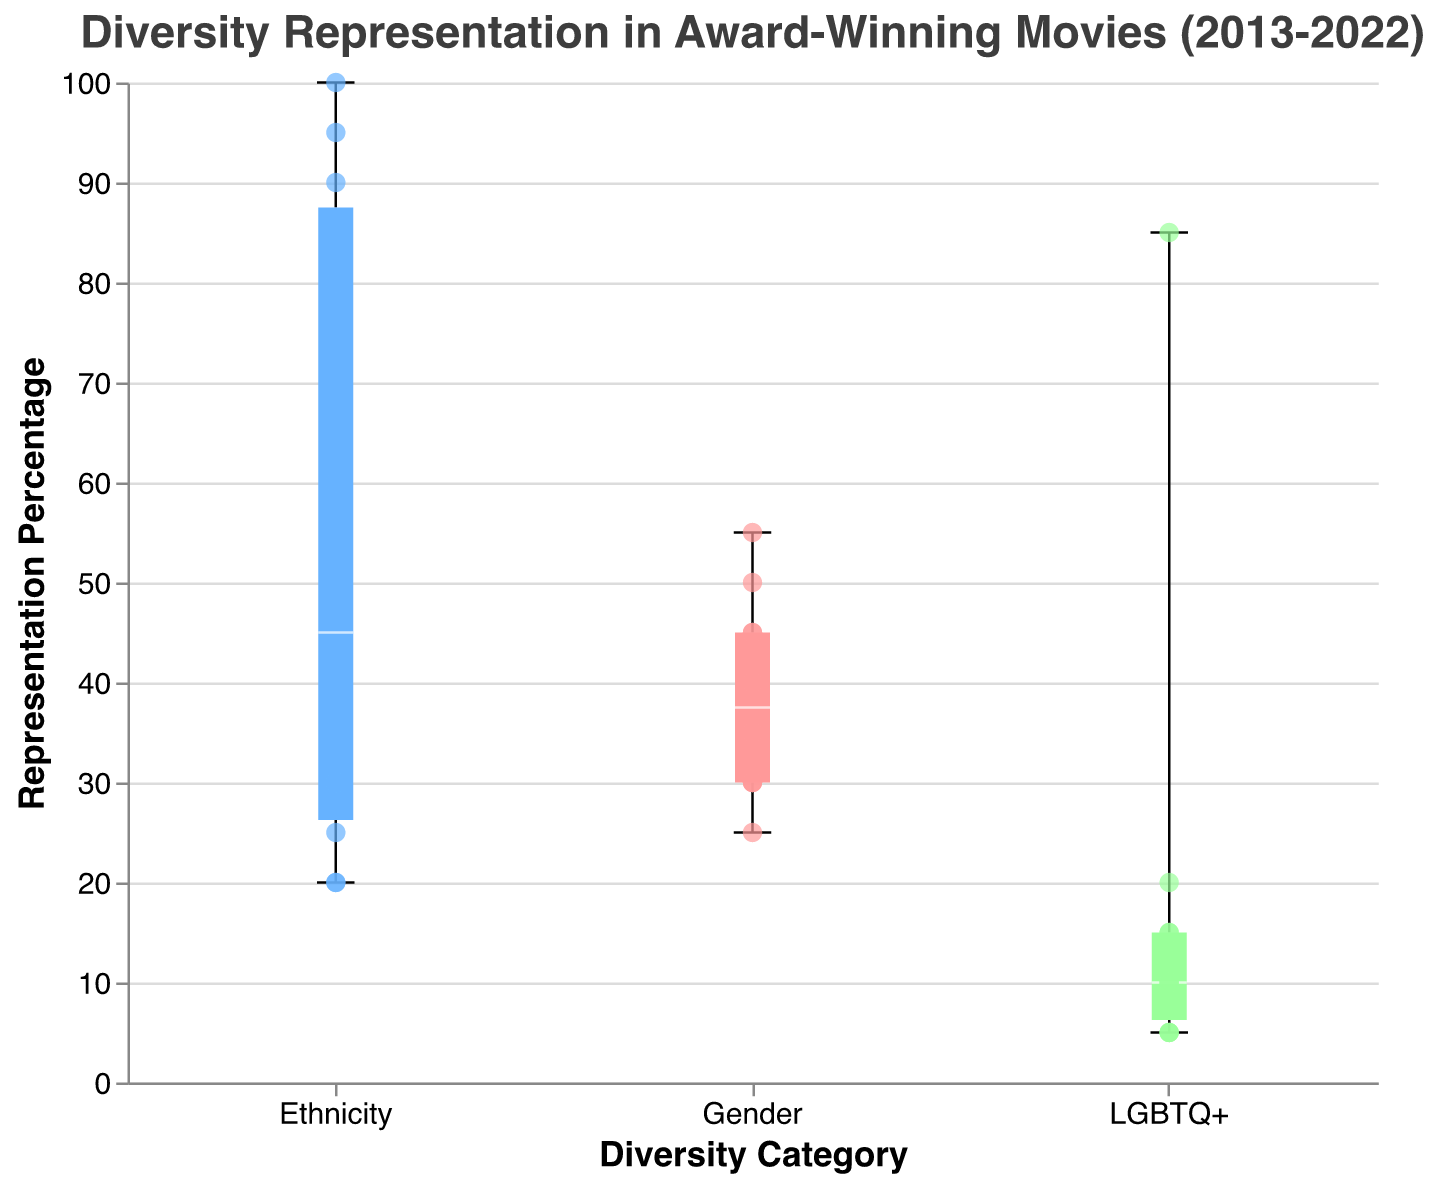How is the title of the box plot described? The title of the box plot is located at the top of the figure, and it indicates the primary subject of the plot, which is the "Diversity Representation in Award-Winning Movies (2013-2022)".
Answer: Diversity Representation in Award-Winning Movies (2013-2022) Which diversity category has the highest individual representation percentage? To determine the highest individual representation percentage, look at the scatter points. The highest scatter point is at 100% for the Ethnicity category in the year 2019 for the movie "Parasite".
Answer: Ethnicity What is the median representation percentage for the Gender category? The median value for the Gender category can be found within the box in the box plot. The median representation percentage for Gender is indicated by a white line across the box around 35%.
Answer: 35% Which movie has the highest representation percentage in the LGBTQ+ category? Scan the scatter points in the LGBTQ+ category. The highest point is 85% for the movie "Moonlight" in 2016.
Answer: Moonlight How does the representation of Ethnicity in 2019 compare with other years? To compare, identify the scatter point for 2019 in the Ethnicity category which is at 100%. This is significantly higher than any other year since all other points are less than 100%.
Answer: Higher than other years Across all years, which diversity category shows the most consistent (least variability) representation percentage? Consistency in a box plot is represented by the tightness of the boxes and shorter whiskers. The Gender category shows the least variability with a narrower box and shorter whiskers compared to Ethnicity and LGBTQ+.
Answer: Gender How many movies have an Ethnicity representation percentage above 50%? Count all the scatter points in the Ethnicity category that are above the 50% threshold. These movies are "12 Years a Slave" (2013), "Moonlight" (2016), "Green Book" (2018), "Parasite" (2019), and "Everything Everywhere All at Once" (2022). There are 5 points.
Answer: 5 What is the interquartile range (IQR) of the LGBTQ+ representation percentage? The IQR is the range between the first quartile (Q1) and the third quartile (Q3). In the LGBTQ+ category, Q1 is around 5%, and Q3 is around 15%. So, the IQR is 15% - 5% = 10%.
Answer: 10% How does the Gender representation percentage for "Birdman" compare to the median Gender representation? Locate the scatter point for "Birdman" in the Gender category which is at 25%. Compare this to the median box line at 35%. The percentage for "Birdman" is lower than the median.
Answer: Lower Which year shows the greatest representation in Ethnicity across all diversity categories? For each year, find the scatter plot points in the Ethnicity category. The highest point is for 2019 with "Parasite" at 100%.
Answer: 2019 